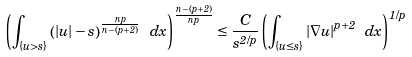Convert formula to latex. <formula><loc_0><loc_0><loc_500><loc_500>\left ( \int _ { \{ u > s \} } \left ( | u | - s \right ) ^ { \frac { n p } { n - ( p + 2 ) } } \ d x \right ) ^ { \frac { n - ( p + 2 ) } { n p } } \leq \frac { C } { s ^ { 2 / p } } \left ( \int _ { \{ u \leq s \} } | \nabla u | ^ { p + 2 } \ d x \right ) ^ { 1 / p }</formula> 